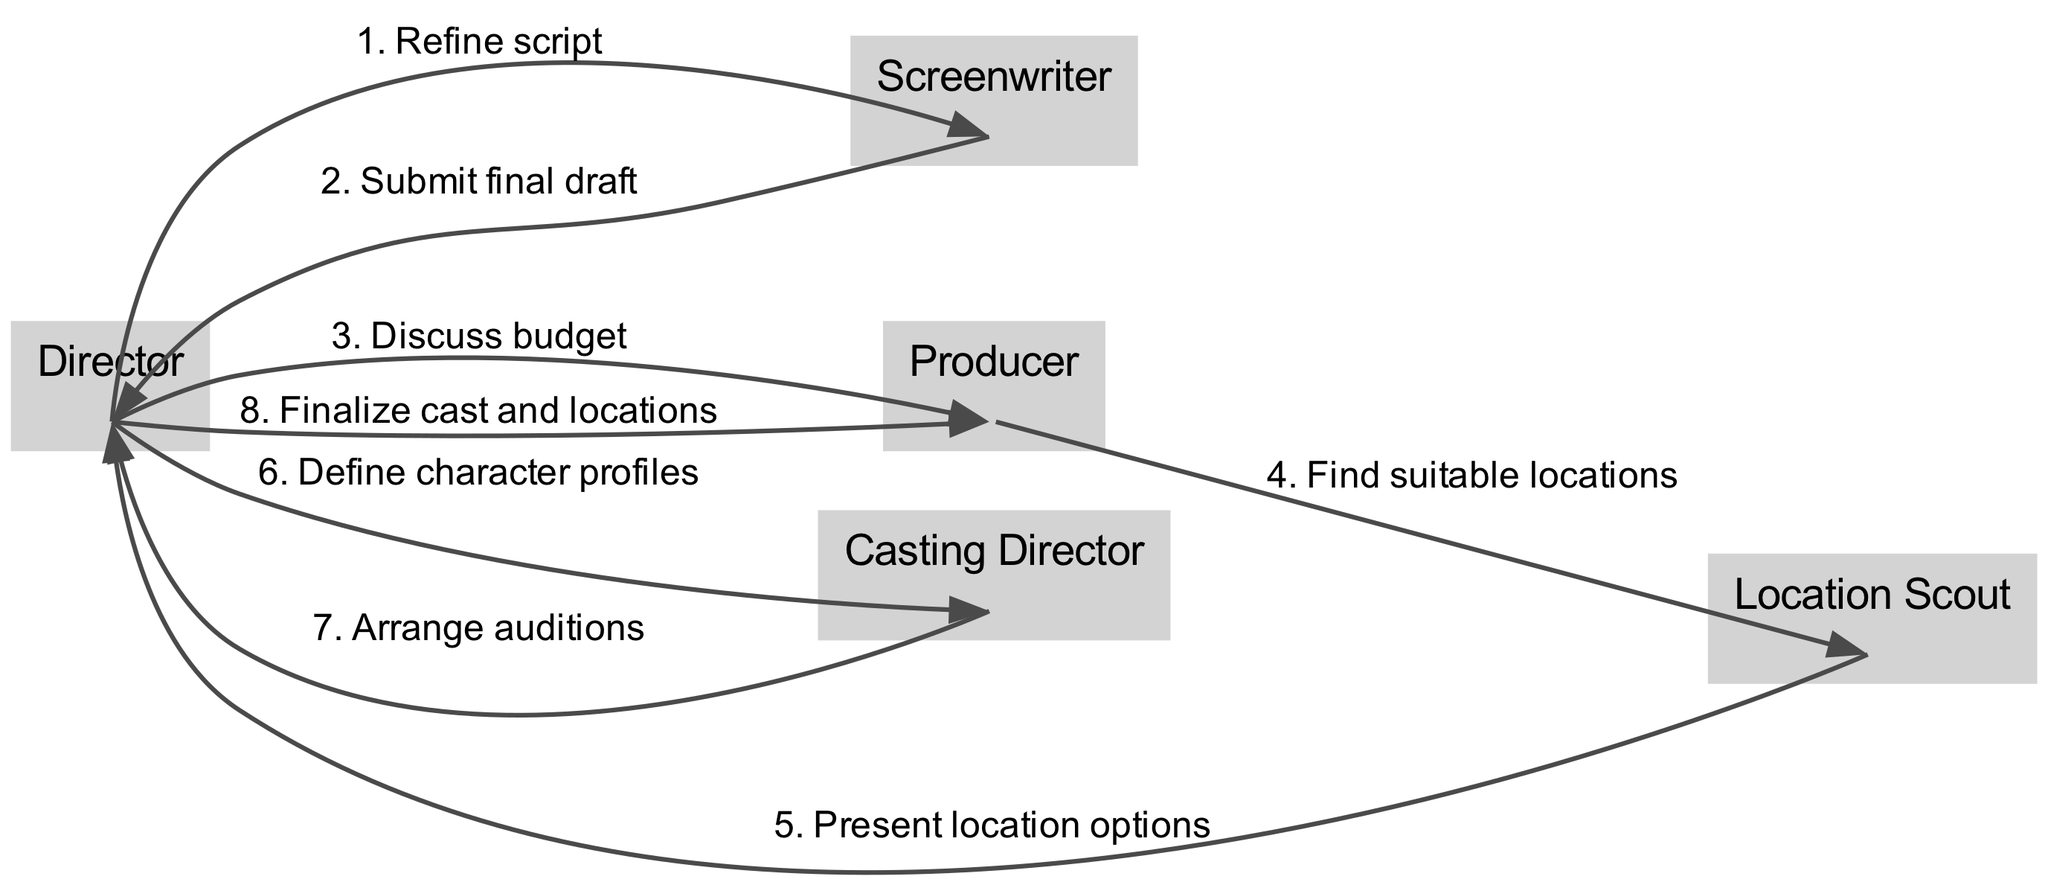What action follows the "Refine script"? According to the sequence of actions, the "Refine script" action by the director is followed by the "Submit final draft" action from the screenwriter.
Answer: Submit final draft Who defines the character profiles? The diagram shows that the character profiles are defined by the director.
Answer: Director How many total actors are involved in the workflow? The diagram lists five actors directly involved in the pre-production workflow for the film.
Answer: Five What is the last action taken in the sequence? By evaluating the sequence flow, the last action taken is "Finalize cast and locations" by the director.
Answer: Finalize cast and locations Which actor presents location options to the director? The location scout is responsible for presenting location options to the director as per the sequence.
Answer: Location Scout What is the immediate action after discussing the budget? Following the "Discuss budget" action with the producer, the next action is for the producer to find suitable locations.
Answer: Find suitable locations Which two actors are connected through the action "Arrange auditions"? The sequence indicates that the casting director arranges auditions for the director, establishing a connection between them.
Answer: Casting Director and Director How many actions are there in total in the sequence? By counting the actions listed in the sequence, we find there are eight actions in total.
Answer: Eight What does the producer do right after discussing the budget? Right after discussing the budget, the producer finds suitable locations, as outlined in the action flow.
Answer: Find suitable locations 